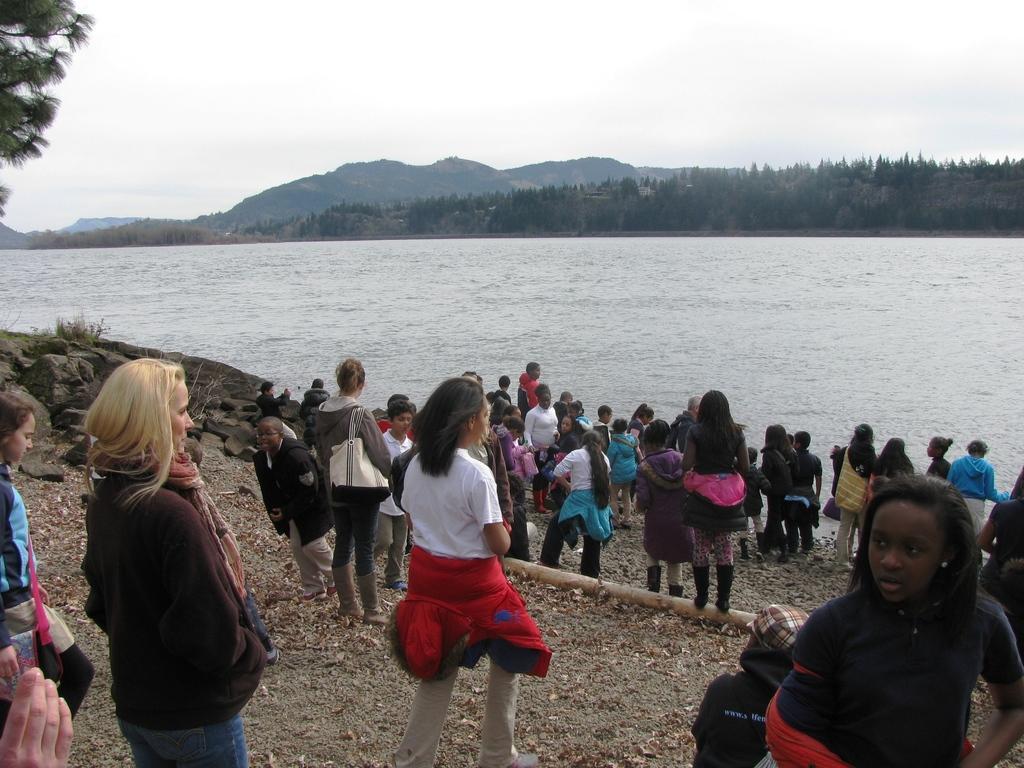How would you summarize this image in a sentence or two? In this picture I see number of people who are standing in front and in the middle of this picture I see number of trees and I see the water and in the background I see the sky and on the top left corner of this image I see the leaves. 